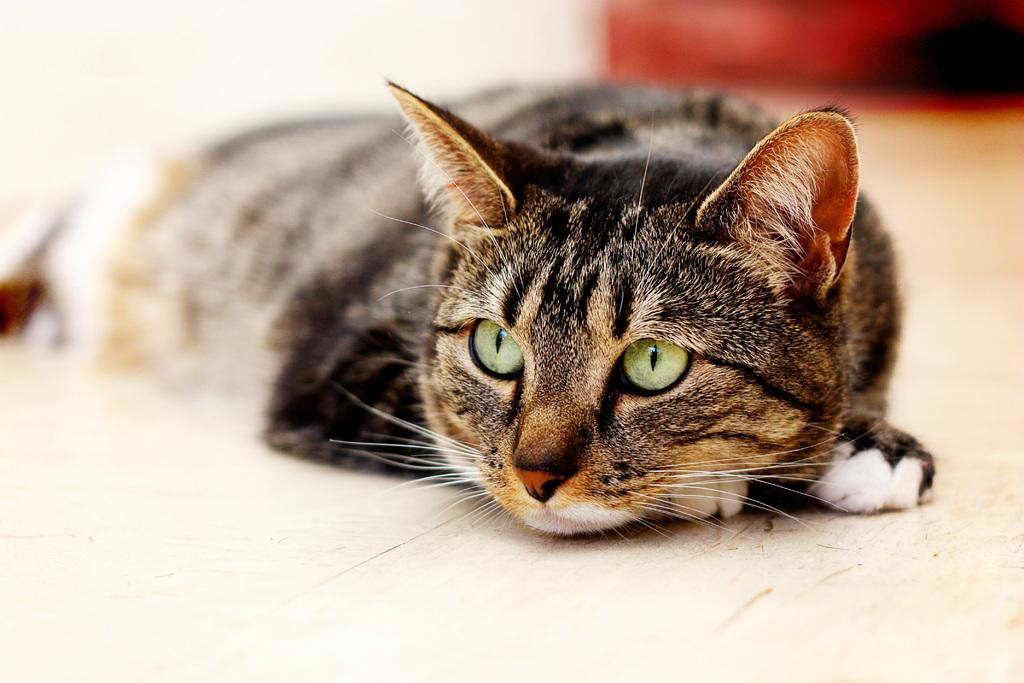What type of animal is in the image? There is a cat in the image. Can you describe the background of the image? The background of the image is blurred. What type of vest is the cat wearing in the image? There is no vest present in the image, and the cat is not wearing any clothing. 